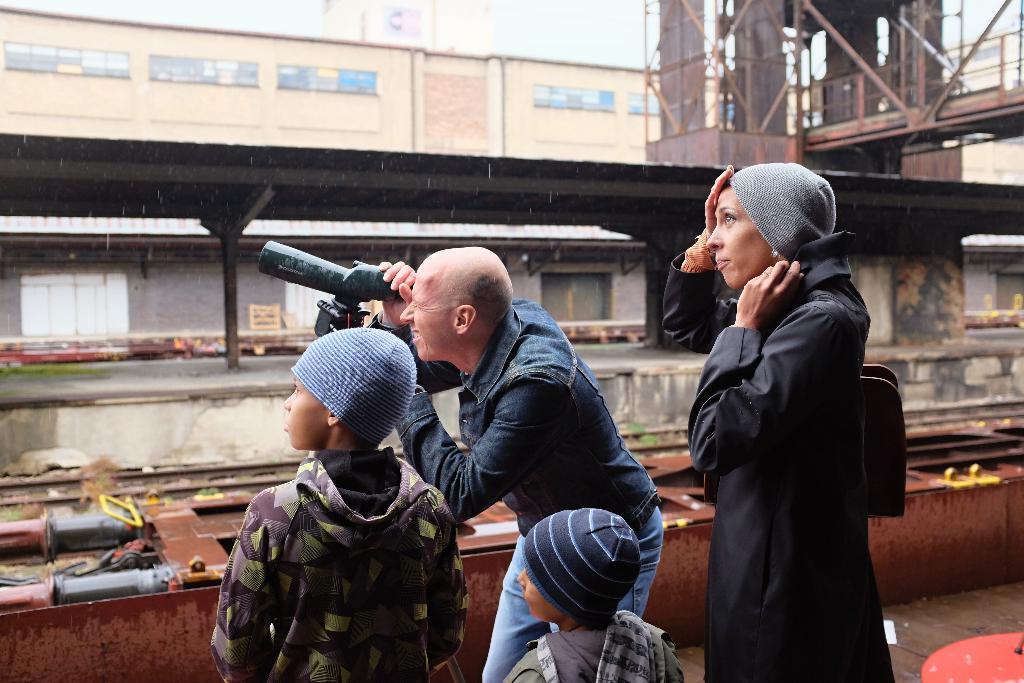How would you summarize this image in a sentence or two? In the center of the image a man is standing and seeing through binocular, beside him three persons are standing and wearing hats. In the background of the image we can see a bridge, shed, building, door, platform, rods, railway track. At the bottom of the image we can see the floor. At the top of the image we can see the sky. 